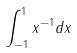<formula> <loc_0><loc_0><loc_500><loc_500>\int _ { - 1 } ^ { 1 } x ^ { - 1 } d x</formula> 